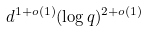<formula> <loc_0><loc_0><loc_500><loc_500>d ^ { 1 + o ( 1 ) } ( \log q ) ^ { 2 + o ( 1 ) }</formula> 